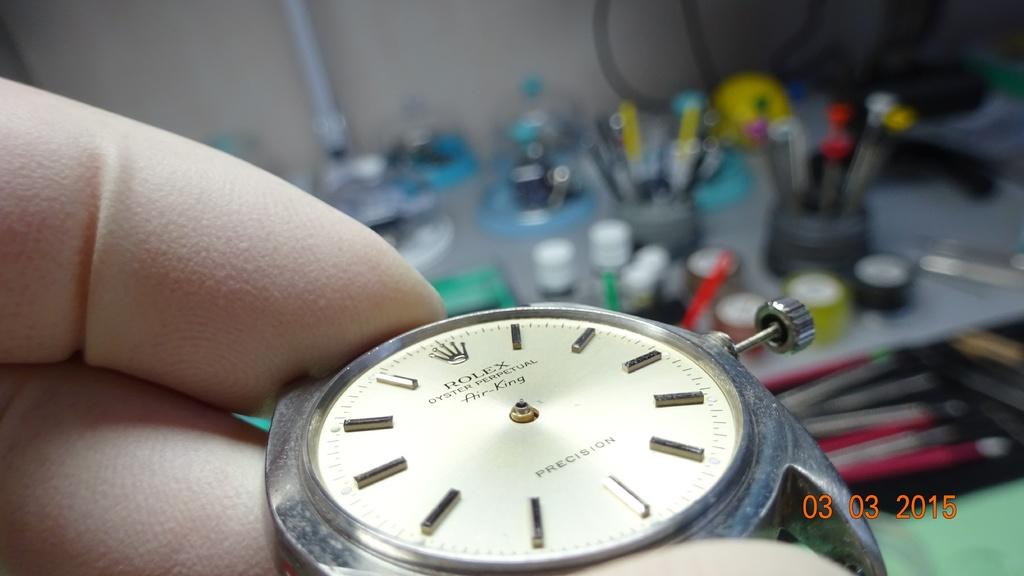Provide a one-sentence caption for the provided image. A person is repairing a Rolex watch in 2015. 